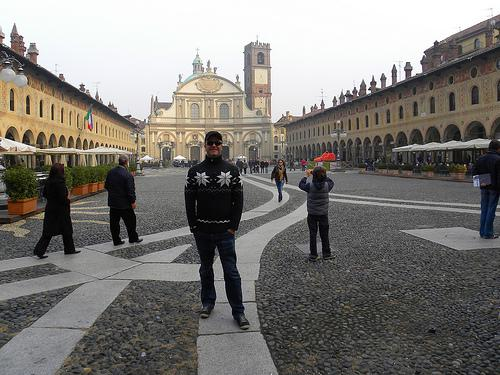Question: when was this?
Choices:
A. Nighttime.
B. Daytime.
C. Summer.
D. Winter.
Answer with the letter. Answer: B Question: how is the photo?
Choices:
A. Blurry.
B. Clear.
C. Fuzzy.
D. Dark.
Answer with the letter. Answer: B Question: what color are the plants?
Choices:
A. Yellow.
B. Brown.
C. Blue.
D. Green.
Answer with the letter. Answer: D Question: what type of scene is this?
Choices:
A. Indoor.
B. Outdoor.
C. Rural.
D. Urban.
Answer with the letter. Answer: B Question: what is the weather?
Choices:
A. Sunny.
B. Cloudy.
C. Rainy.
D. Snowy.
Answer with the letter. Answer: B Question: what covers the sky?
Choices:
A. Stars.
B. Precipitation.
C. Night.
D. Clouds.
Answer with the letter. Answer: D 